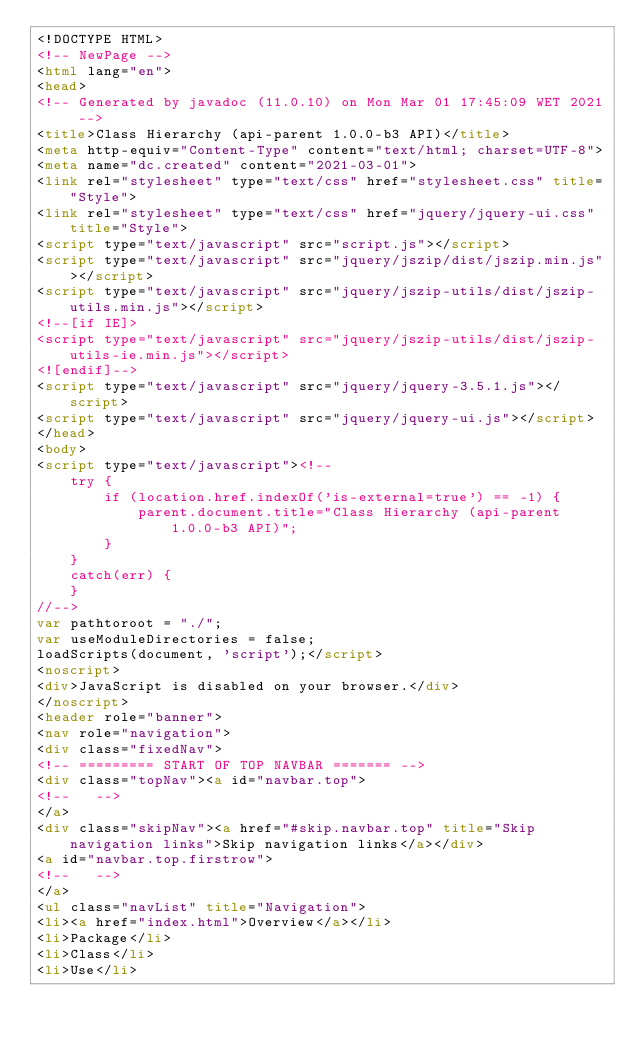<code> <loc_0><loc_0><loc_500><loc_500><_HTML_><!DOCTYPE HTML>
<!-- NewPage -->
<html lang="en">
<head>
<!-- Generated by javadoc (11.0.10) on Mon Mar 01 17:45:09 WET 2021 -->
<title>Class Hierarchy (api-parent 1.0.0-b3 API)</title>
<meta http-equiv="Content-Type" content="text/html; charset=UTF-8">
<meta name="dc.created" content="2021-03-01">
<link rel="stylesheet" type="text/css" href="stylesheet.css" title="Style">
<link rel="stylesheet" type="text/css" href="jquery/jquery-ui.css" title="Style">
<script type="text/javascript" src="script.js"></script>
<script type="text/javascript" src="jquery/jszip/dist/jszip.min.js"></script>
<script type="text/javascript" src="jquery/jszip-utils/dist/jszip-utils.min.js"></script>
<!--[if IE]>
<script type="text/javascript" src="jquery/jszip-utils/dist/jszip-utils-ie.min.js"></script>
<![endif]-->
<script type="text/javascript" src="jquery/jquery-3.5.1.js"></script>
<script type="text/javascript" src="jquery/jquery-ui.js"></script>
</head>
<body>
<script type="text/javascript"><!--
    try {
        if (location.href.indexOf('is-external=true') == -1) {
            parent.document.title="Class Hierarchy (api-parent 1.0.0-b3 API)";
        }
    }
    catch(err) {
    }
//-->
var pathtoroot = "./";
var useModuleDirectories = false;
loadScripts(document, 'script');</script>
<noscript>
<div>JavaScript is disabled on your browser.</div>
</noscript>
<header role="banner">
<nav role="navigation">
<div class="fixedNav">
<!-- ========= START OF TOP NAVBAR ======= -->
<div class="topNav"><a id="navbar.top">
<!--   -->
</a>
<div class="skipNav"><a href="#skip.navbar.top" title="Skip navigation links">Skip navigation links</a></div>
<a id="navbar.top.firstrow">
<!--   -->
</a>
<ul class="navList" title="Navigation">
<li><a href="index.html">Overview</a></li>
<li>Package</li>
<li>Class</li>
<li>Use</li></code> 